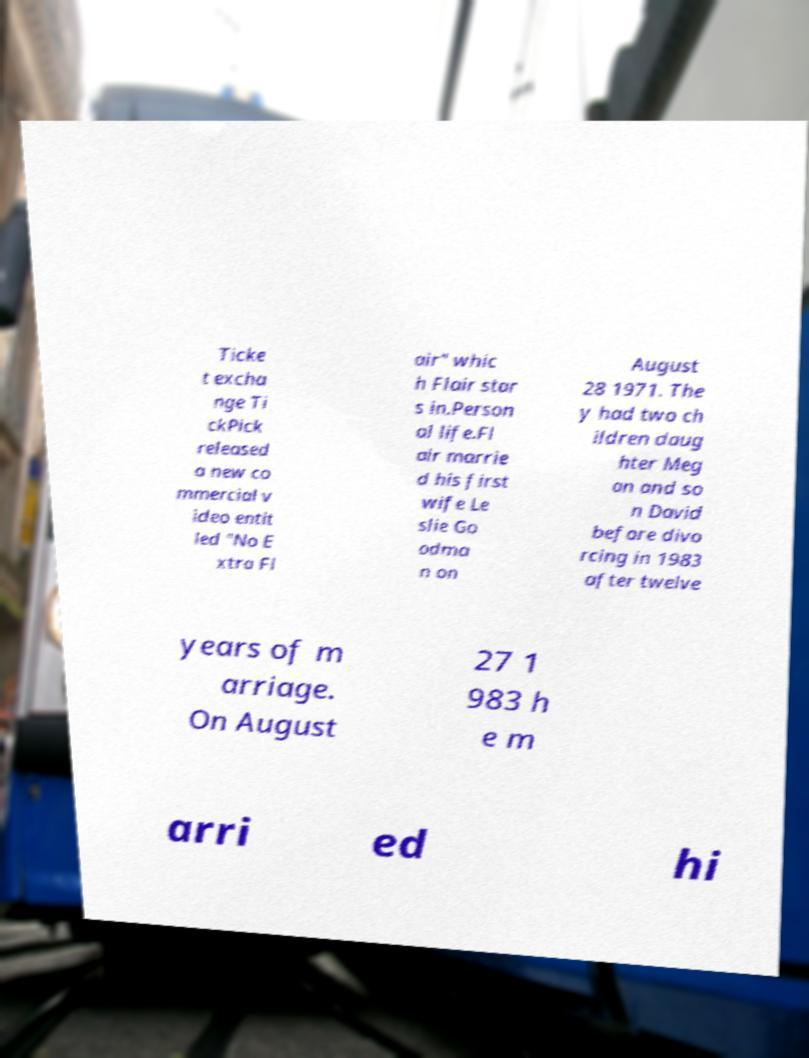Could you assist in decoding the text presented in this image and type it out clearly? Ticke t excha nge Ti ckPick released a new co mmercial v ideo entit led "No E xtra Fl air" whic h Flair star s in.Person al life.Fl air marrie d his first wife Le slie Go odma n on August 28 1971. The y had two ch ildren daug hter Meg an and so n David before divo rcing in 1983 after twelve years of m arriage. On August 27 1 983 h e m arri ed hi 